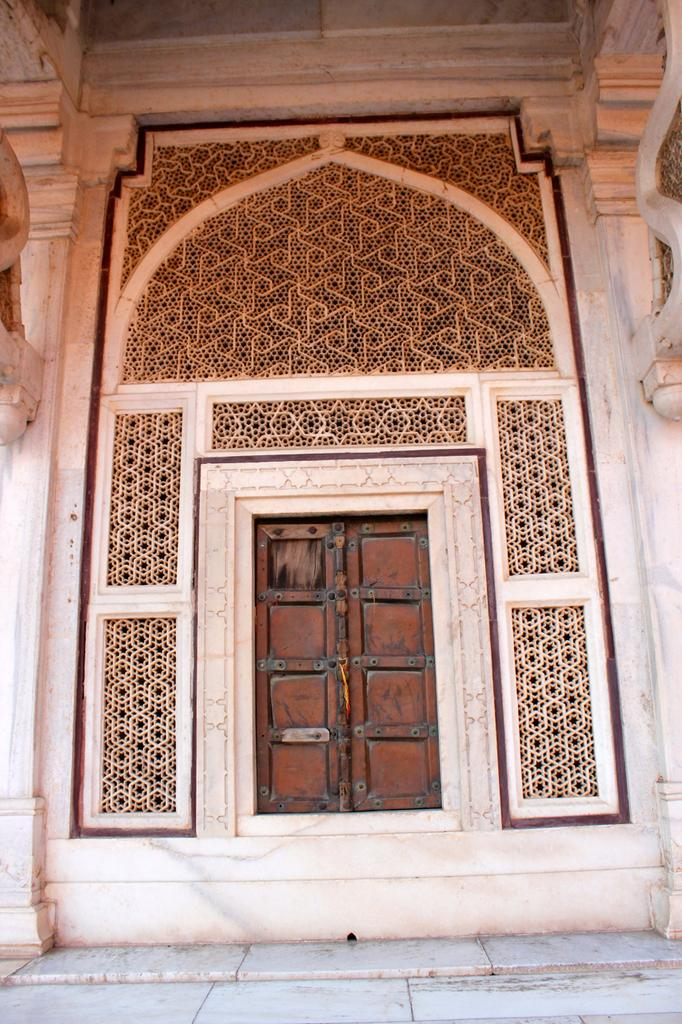What is the main structure in the center of the image? There is a building in the center of the image. What type of architectural feature can be seen in the image? There is a wall and pillars in the image. What type of door is present in the image? There is a wooden door in the image. What other objects can be seen in the image? There are other objects in the image, but their specific details are not mentioned in the provided facts. What design is present on the wall? There is a design on the wall in the image. Where is the desk located in the image? There is no desk present in the image. What type of club is featured in the image? There is no club present in the image. 